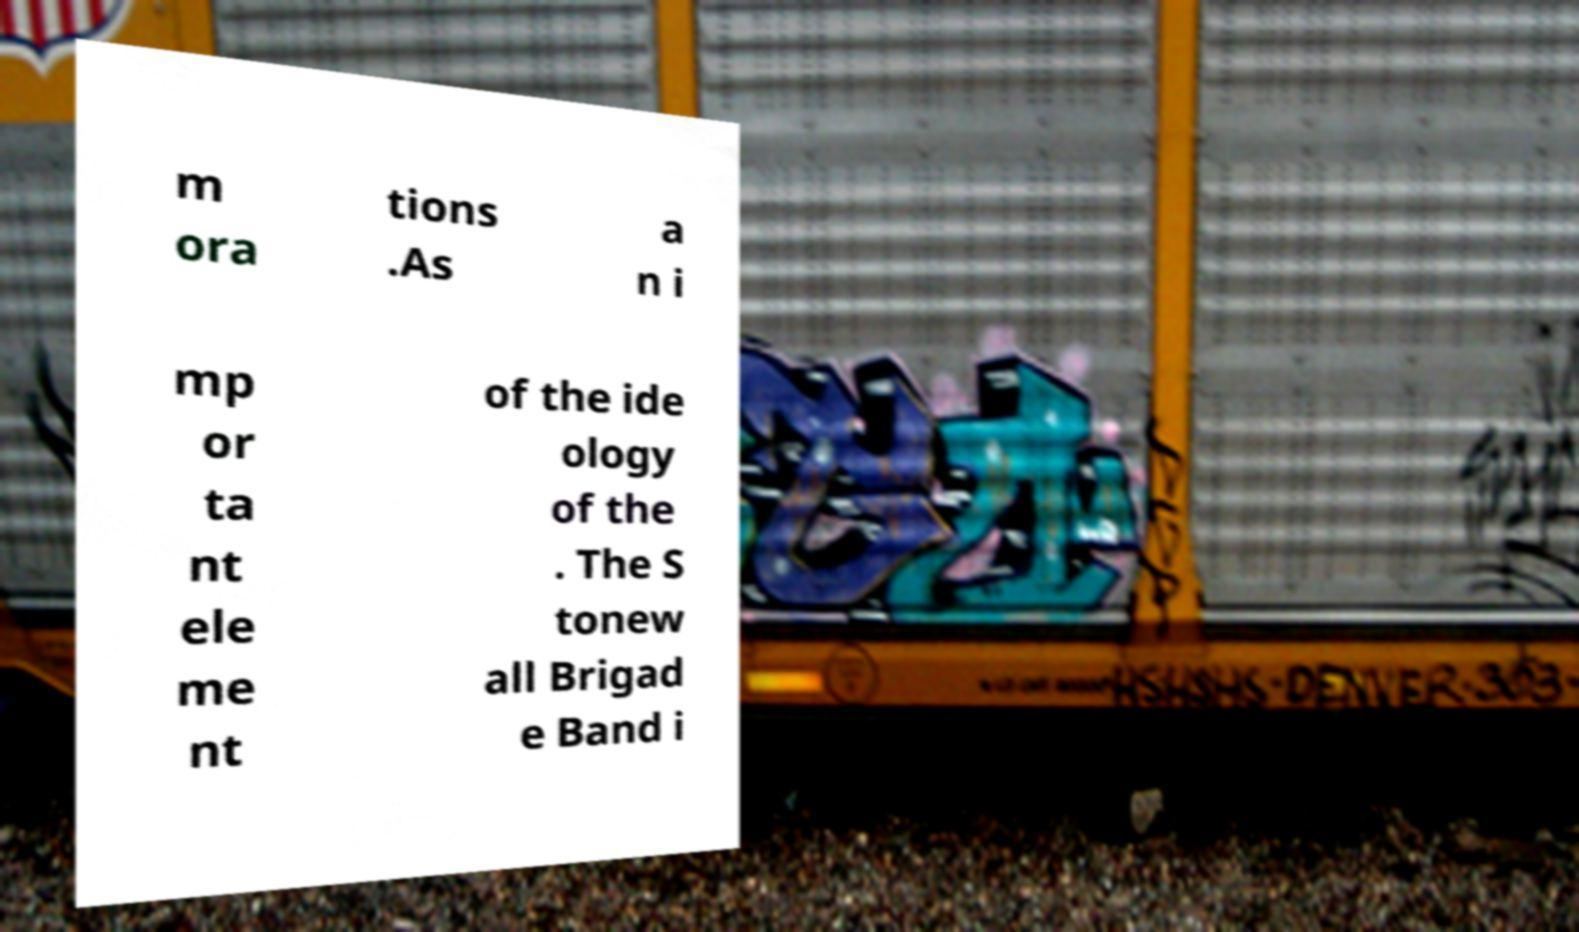Can you accurately transcribe the text from the provided image for me? m ora tions .As a n i mp or ta nt ele me nt of the ide ology of the . The S tonew all Brigad e Band i 